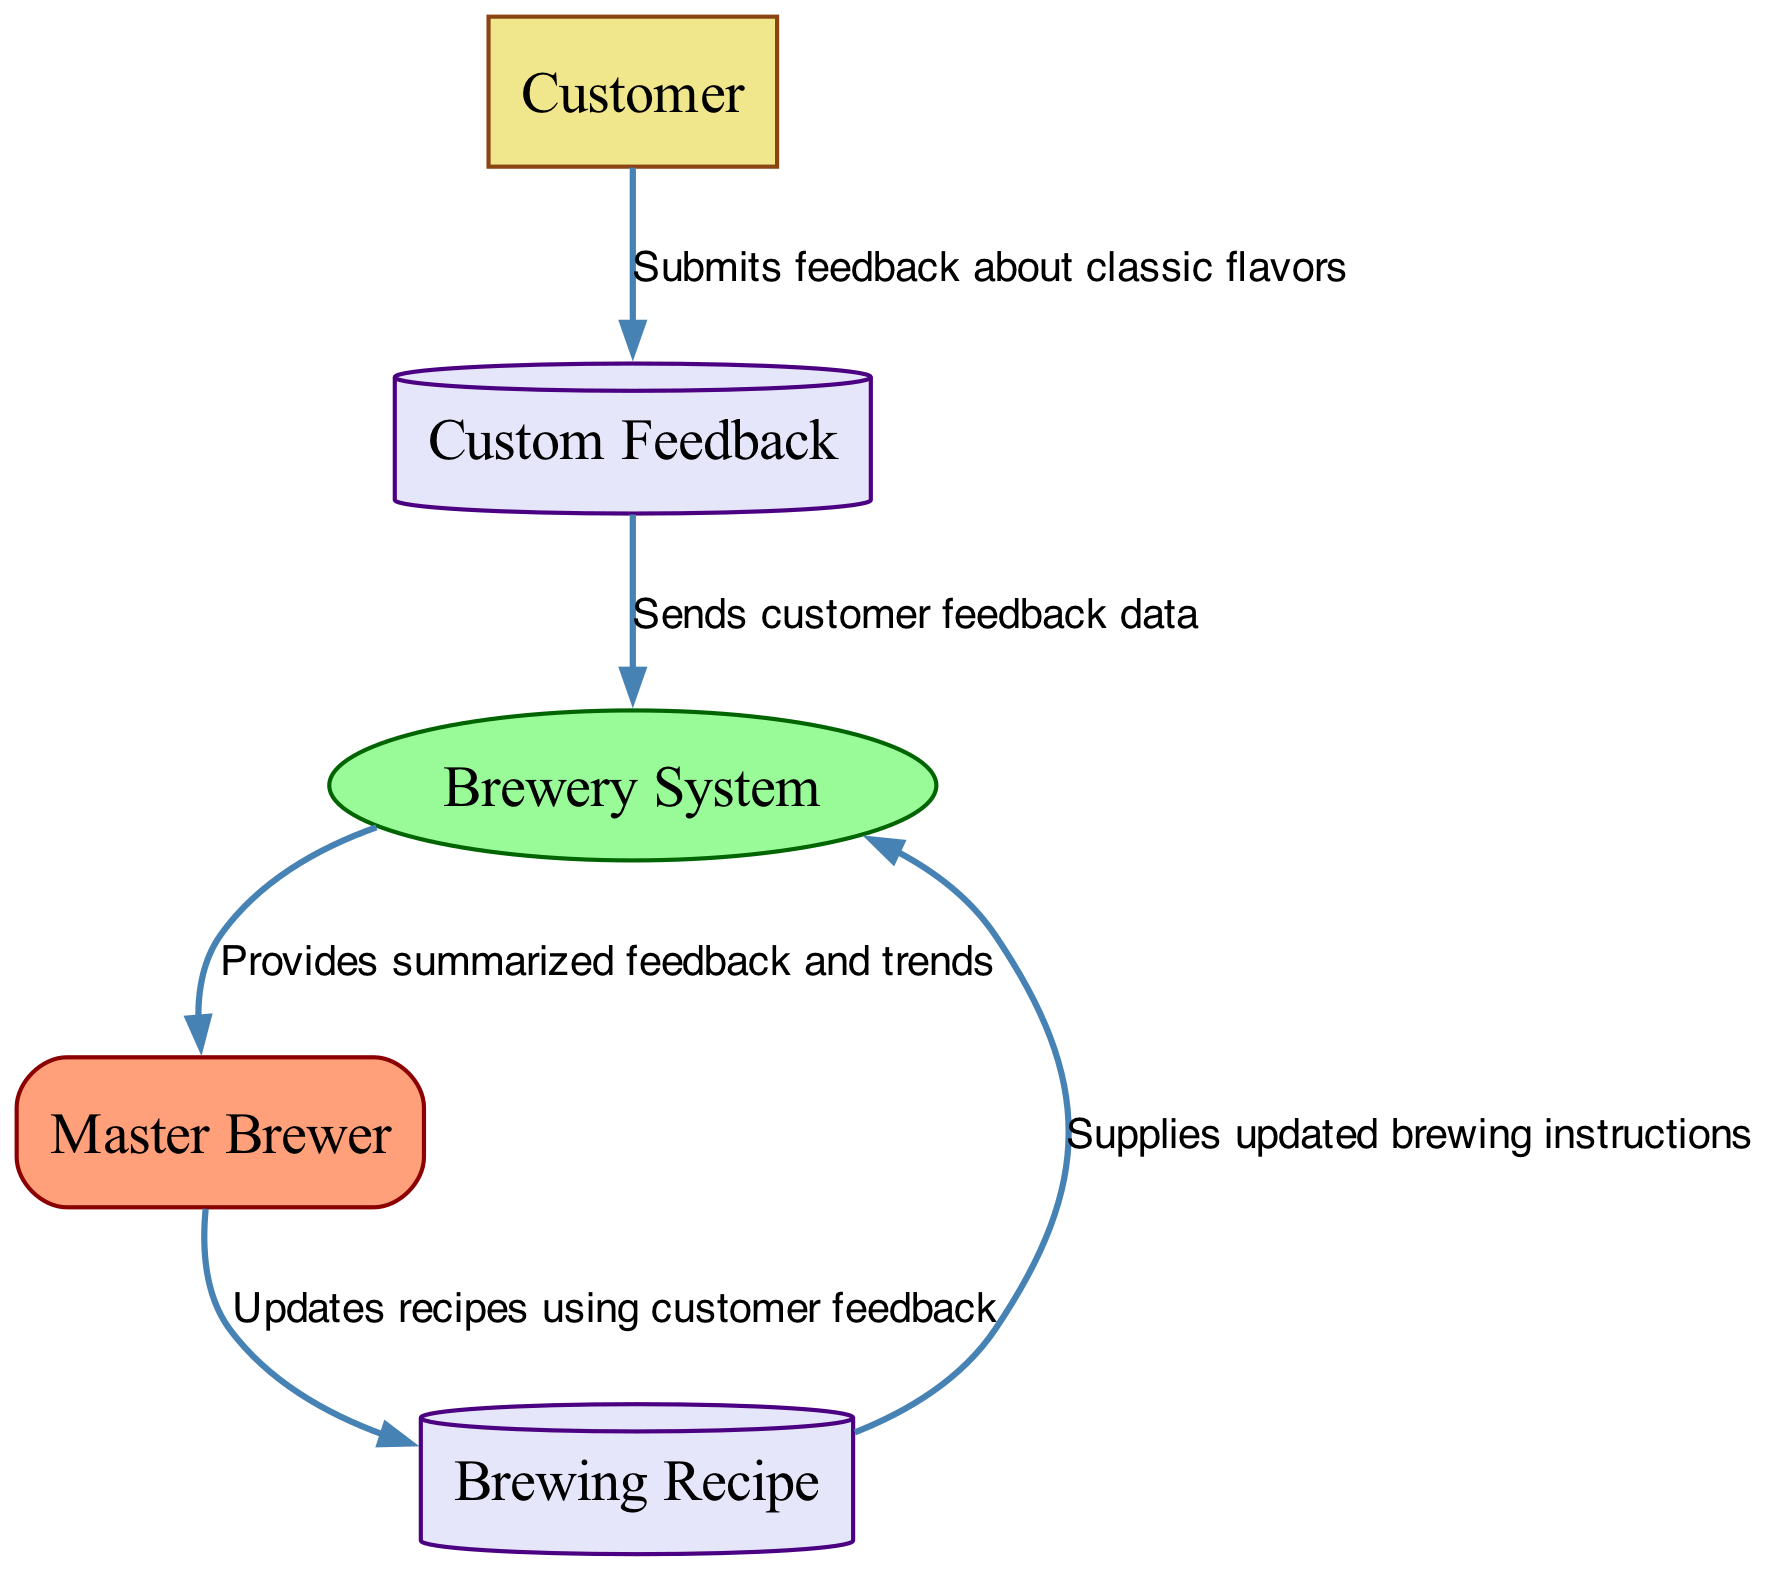What is the source of feedback data in the diagram? The source of feedback data is the "Customer." They submit feedback about classic flavors, which starts the flow of information in the diagram.
Answer: Customer How many data stores are in the diagram? There are two data stores in the diagram: "Custom Feedback" and "Brewing Recipe." Both serve as locations for storing relevant information.
Answer: 2 What does the Brewery System provide to the Master Brewer? The Brewery System provides summarized feedback and trends to the Master Brewer. This information allows for better decision-making regarding brewing.
Answer: Summarized feedback and trends Which process updates the Brewing Recipe? The process that updates the Brewing Recipe is the "Brewery System." It facilitates the integration of customer feedback into the recipes used for brewing classic flavors.
Answer: Brewery System What type of entity is the Master Brewer? The Master Brewer is classified as an "Internal Entity," indicating their role within the brewery's system, managing and making decisions based on the data flow.
Answer: Internal Entity How does customer feedback flow to the Brewing Recipe? Customer feedback flows from the Customer to "Custom Feedback," then to the "Brewery System," which passes the information to the Master Brewer who updates the "Brewing Recipe." This illustrates a sequential flow of information that correlates feedback to recipe adjustments.
Answer: Sequential flow Which data store supplies updated brewing instructions to the Brewery System? The data store that supplies updated brewing instructions is the "Brewing Recipe." It contains the necessary instructions that reflect the updates made by the Master Brewer based on customer feedback.
Answer: Brewing Recipe What is the first step in the customer feedback loop? The first step in the customer feedback loop is when the "Customer" submits feedback about classic flavors. This action initiates the entire feedback process.
Answer: Customer submits feedback 